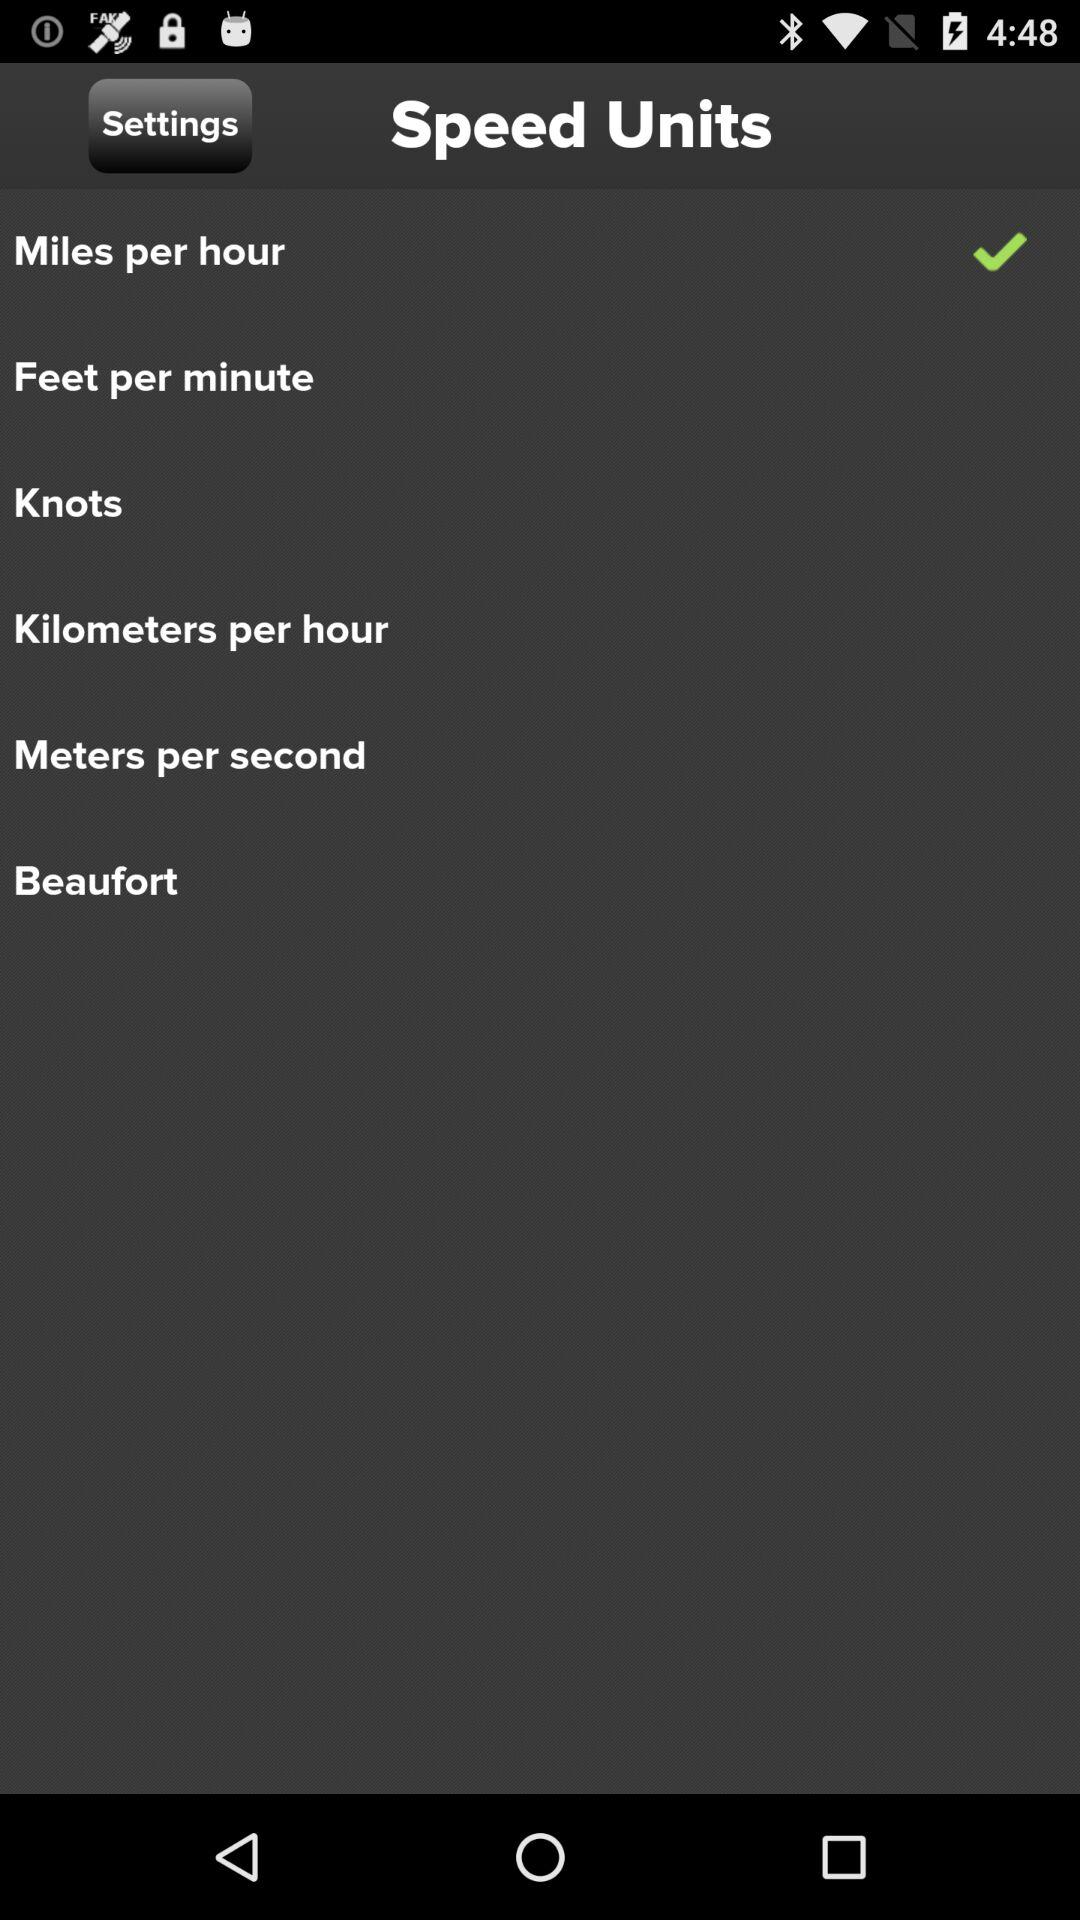How many of the speed units have check marks next to them?
Answer the question using a single word or phrase. 1 